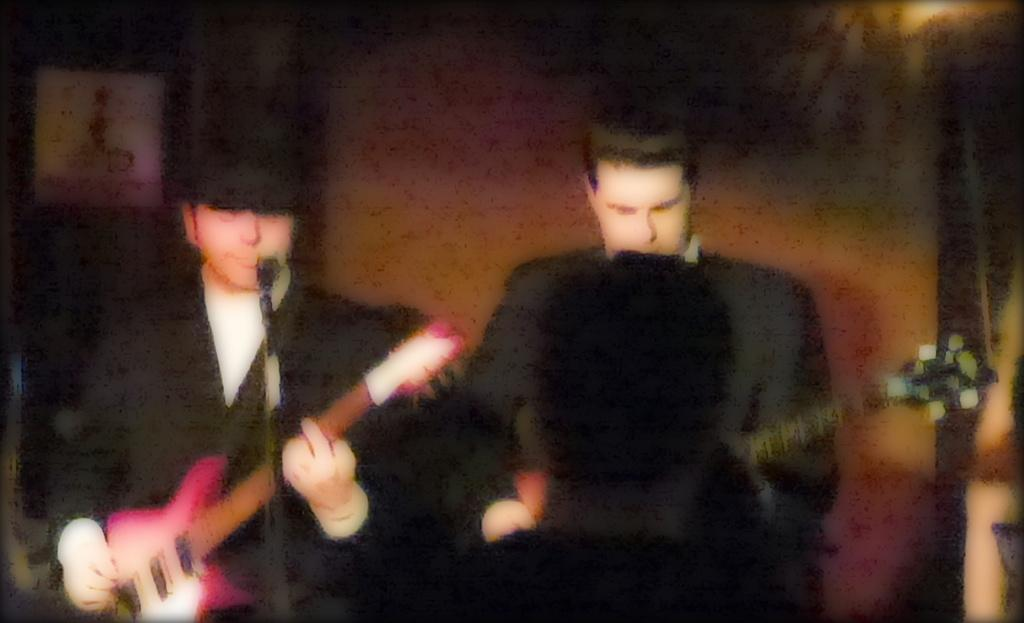What are the persons in the image doing? The persons in the image are playing a musical instrument. What object is in front of the persons? There is a microphone in front of the persons. How would you describe the background of the image? The background appears blurry. What type of treatment is being administered to the persons in the image? There is no indication of any treatment being administered to the persons in the image; they are simply playing a musical instrument. 